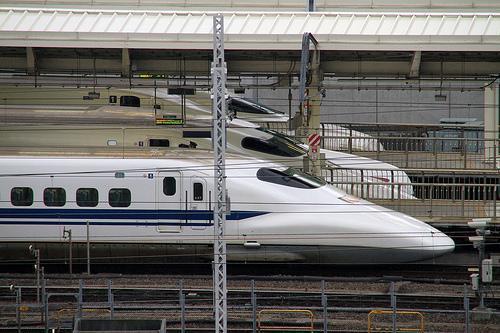How many trains are in this image?
Give a very brief answer. 3. 